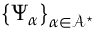Convert formula to latex. <formula><loc_0><loc_0><loc_500><loc_500>\left \{ \Psi _ { \alpha } \right \} _ { \alpha \in \mathcal { A } ^ { ^ { * } } }</formula> 